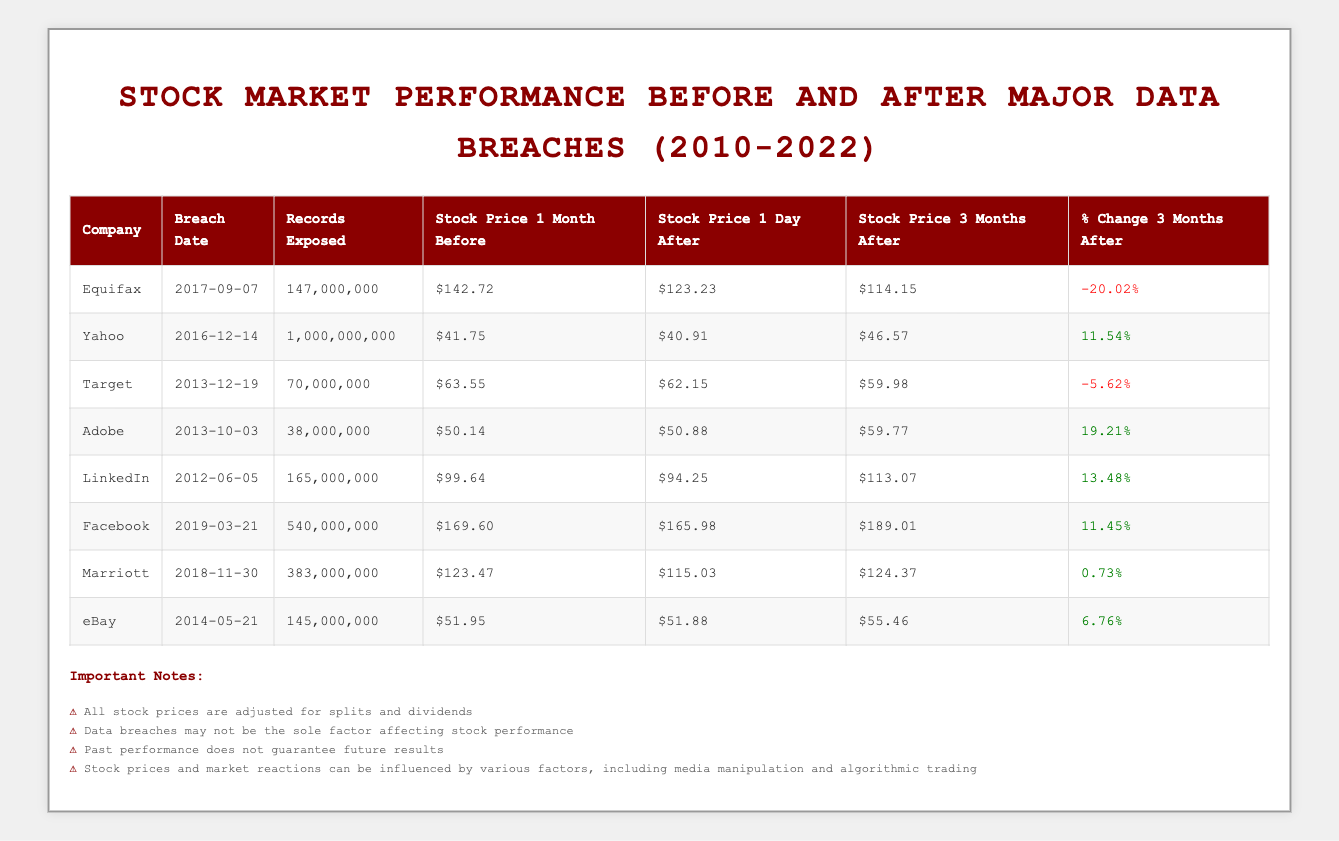What was the stock price of Equifax one month before the breach? According to the table, the stock price of Equifax one month before the breach on September 7, 2017, was $142.72.
Answer: $142.72 How many records were exposed in the Yahoo breach? The table indicates that the Yahoo breach on December 14, 2016, involved 1,000,000,000 records being exposed.
Answer: 1,000,000,000 What was the average stock price change three months after the breaches for the companies listed? First, we add the percentage changes for each company: (-20.02 + 11.54 - 5.62 + 19.21 + 13.48 + 11.45 + 0.73 + 6.76) = 37.53. Then, we divide by the total number of companies (8) to find the average: 37.53 / 8 = 4.69.
Answer: 4.69 Did Equifax experience a positive stock price change three months after the data breach? Looking at the table, Equifax has a percentage change of -20.02%, indicating a decline. Therefore, the answer is no.
Answer: No Which company showed the highest percentage increase in stock price three months after the breach? By evaluating the "% Change 3 Months After" column, Adobe showed the highest increase of 19.21%.
Answer: Adobe How many companies had a negative stock price change three months after their respective breaches? Analyzing the "% Change 3 Months After" column, Equifax and Target had negative changes (-20.02% and -5.62%, respectively). Thus, there are two companies with negative changes.
Answer: 2 What was the stock price change for Marriott from one day after to three months after the breach? The stock price for Marriott one day after the breach was $115.03, and three months later it was $124.37. The change is calculated as $124.37 - $115.03 = $9.34.
Answer: $9.34 Was LinkedIn's stock price higher three months after the breach than it was one month prior to the breach? The stock price one month before was $99.64 and three months after it was $113.07. Since $113.07 is greater than $99.64, the answer is yes.
Answer: Yes Which company experienced a decrease in stock price on the day after the breach compared to one month before? By checking the table, Equifax had a stock price decrease from $142.72 to $123.23, which confirms it decreased the day after the breach.
Answer: Equifax 